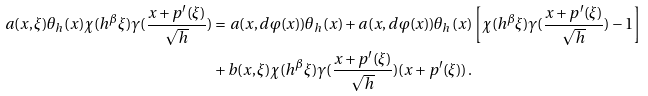<formula> <loc_0><loc_0><loc_500><loc_500>a ( x , \xi ) \theta _ { h } ( x ) \chi ( h ^ { \beta } \xi ) \gamma ( \frac { x + p ^ { \prime } ( \xi ) } { \sqrt { h } } ) & = a ( x , d \varphi ( x ) ) \theta _ { h } ( x ) + a ( x , d \varphi ( x ) ) \theta _ { h } ( x ) \left [ \chi ( h ^ { \beta } \xi ) \gamma ( \frac { x + p ^ { \prime } ( \xi ) } { \sqrt { h } } ) - 1 \right ] \\ & + b ( x , \xi ) \chi ( h ^ { \beta } \xi ) \gamma ( \frac { x + p ^ { \prime } ( \xi ) } { \sqrt { h } } ) ( x + p ^ { \prime } ( \xi ) ) \, .</formula> 